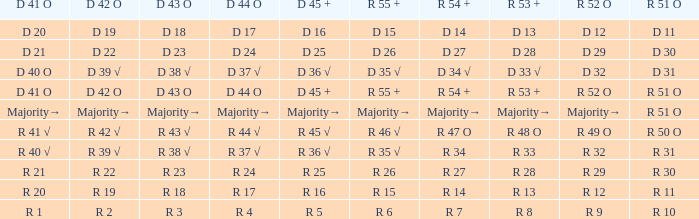What is the value of D 42 O that has an R 53 + value of r 8? R 2. 